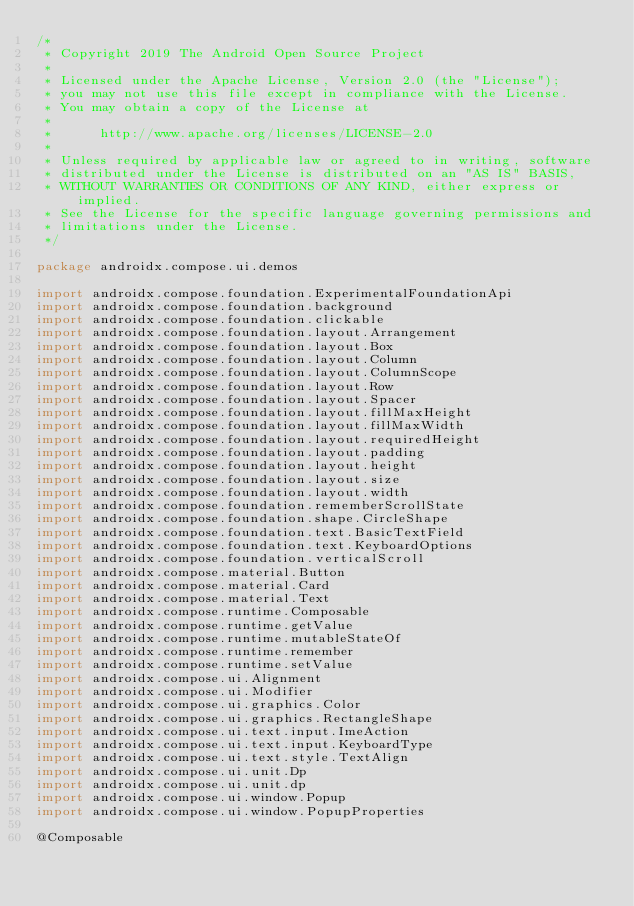Convert code to text. <code><loc_0><loc_0><loc_500><loc_500><_Kotlin_>/*
 * Copyright 2019 The Android Open Source Project
 *
 * Licensed under the Apache License, Version 2.0 (the "License");
 * you may not use this file except in compliance with the License.
 * You may obtain a copy of the License at
 *
 *      http://www.apache.org/licenses/LICENSE-2.0
 *
 * Unless required by applicable law or agreed to in writing, software
 * distributed under the License is distributed on an "AS IS" BASIS,
 * WITHOUT WARRANTIES OR CONDITIONS OF ANY KIND, either express or implied.
 * See the License for the specific language governing permissions and
 * limitations under the License.
 */

package androidx.compose.ui.demos

import androidx.compose.foundation.ExperimentalFoundationApi
import androidx.compose.foundation.background
import androidx.compose.foundation.clickable
import androidx.compose.foundation.layout.Arrangement
import androidx.compose.foundation.layout.Box
import androidx.compose.foundation.layout.Column
import androidx.compose.foundation.layout.ColumnScope
import androidx.compose.foundation.layout.Row
import androidx.compose.foundation.layout.Spacer
import androidx.compose.foundation.layout.fillMaxHeight
import androidx.compose.foundation.layout.fillMaxWidth
import androidx.compose.foundation.layout.requiredHeight
import androidx.compose.foundation.layout.padding
import androidx.compose.foundation.layout.height
import androidx.compose.foundation.layout.size
import androidx.compose.foundation.layout.width
import androidx.compose.foundation.rememberScrollState
import androidx.compose.foundation.shape.CircleShape
import androidx.compose.foundation.text.BasicTextField
import androidx.compose.foundation.text.KeyboardOptions
import androidx.compose.foundation.verticalScroll
import androidx.compose.material.Button
import androidx.compose.material.Card
import androidx.compose.material.Text
import androidx.compose.runtime.Composable
import androidx.compose.runtime.getValue
import androidx.compose.runtime.mutableStateOf
import androidx.compose.runtime.remember
import androidx.compose.runtime.setValue
import androidx.compose.ui.Alignment
import androidx.compose.ui.Modifier
import androidx.compose.ui.graphics.Color
import androidx.compose.ui.graphics.RectangleShape
import androidx.compose.ui.text.input.ImeAction
import androidx.compose.ui.text.input.KeyboardType
import androidx.compose.ui.text.style.TextAlign
import androidx.compose.ui.unit.Dp
import androidx.compose.ui.unit.dp
import androidx.compose.ui.window.Popup
import androidx.compose.ui.window.PopupProperties

@Composable</code> 